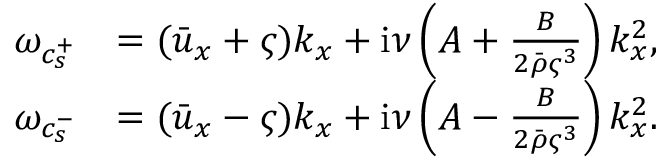<formula> <loc_0><loc_0><loc_500><loc_500>\begin{array} { r l } { \omega _ { c _ { s } ^ { + } } } & { = ( \bar { u } _ { x } + \varsigma ) k _ { x } + i \nu \left ( A + \frac { B } { 2 \bar { \rho } \varsigma ^ { 3 } } \right ) k _ { x } ^ { 2 } , } \\ { \omega _ { c _ { s } ^ { - } } } & { = ( \bar { u } _ { x } - \varsigma ) k _ { x } + i \nu \left ( A - \frac { B } { 2 \bar { \rho } \varsigma ^ { 3 } } \right ) k _ { x } ^ { 2 } . } \end{array}</formula> 